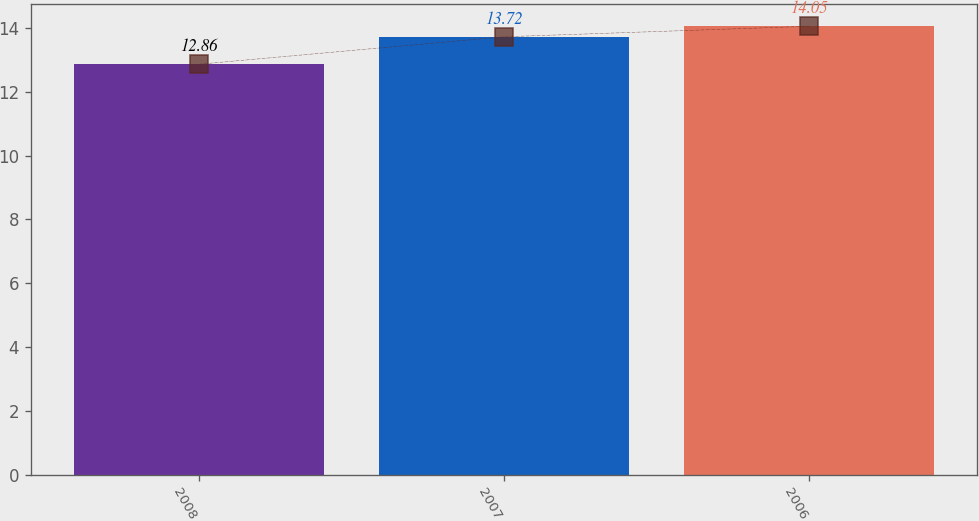Convert chart. <chart><loc_0><loc_0><loc_500><loc_500><bar_chart><fcel>2008<fcel>2007<fcel>2006<nl><fcel>12.86<fcel>13.72<fcel>14.05<nl></chart> 